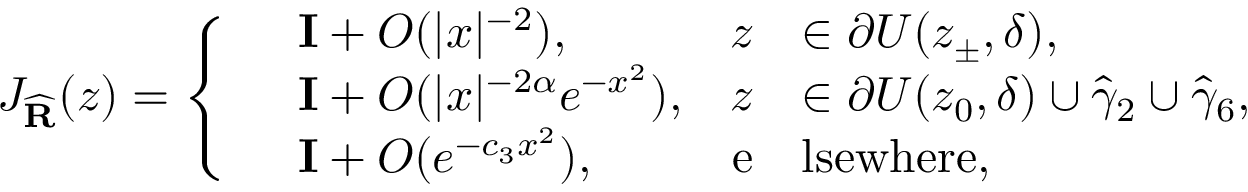Convert formula to latex. <formula><loc_0><loc_0><loc_500><loc_500>J _ { \widehat { R } } ( z ) = \left \{ \begin{array} { r l r l } & { I + O ( | x | ^ { - 2 } ) , } & { z } & { \in \partial U ( z _ { \pm } , \delta ) , } \\ & { I + O ( | x | ^ { - 2 \alpha } e ^ { - x ^ { 2 } } ) , } & { z } & { \in \partial U ( z _ { 0 } , \delta ) \cup \widehat { \gamma } _ { 2 } \cup \widehat { \gamma } _ { 6 } , } \\ & { I + O ( e ^ { - c _ { 3 } x ^ { 2 } } ) , } & { e } & { l s e w h e r e , } \end{array}</formula> 